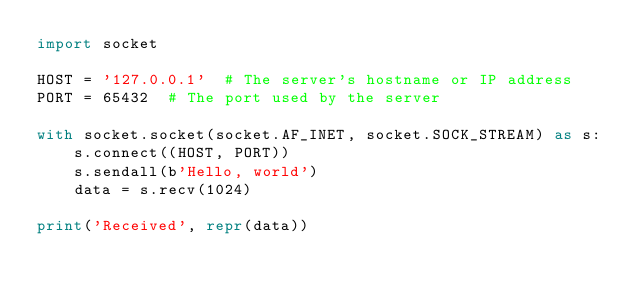Convert code to text. <code><loc_0><loc_0><loc_500><loc_500><_Python_>import socket

HOST = '127.0.0.1'  # The server's hostname or IP address
PORT = 65432  # The port used by the server

with socket.socket(socket.AF_INET, socket.SOCK_STREAM) as s:
    s.connect((HOST, PORT))
    s.sendall(b'Hello, world')
    data = s.recv(1024)

print('Received', repr(data))
</code> 